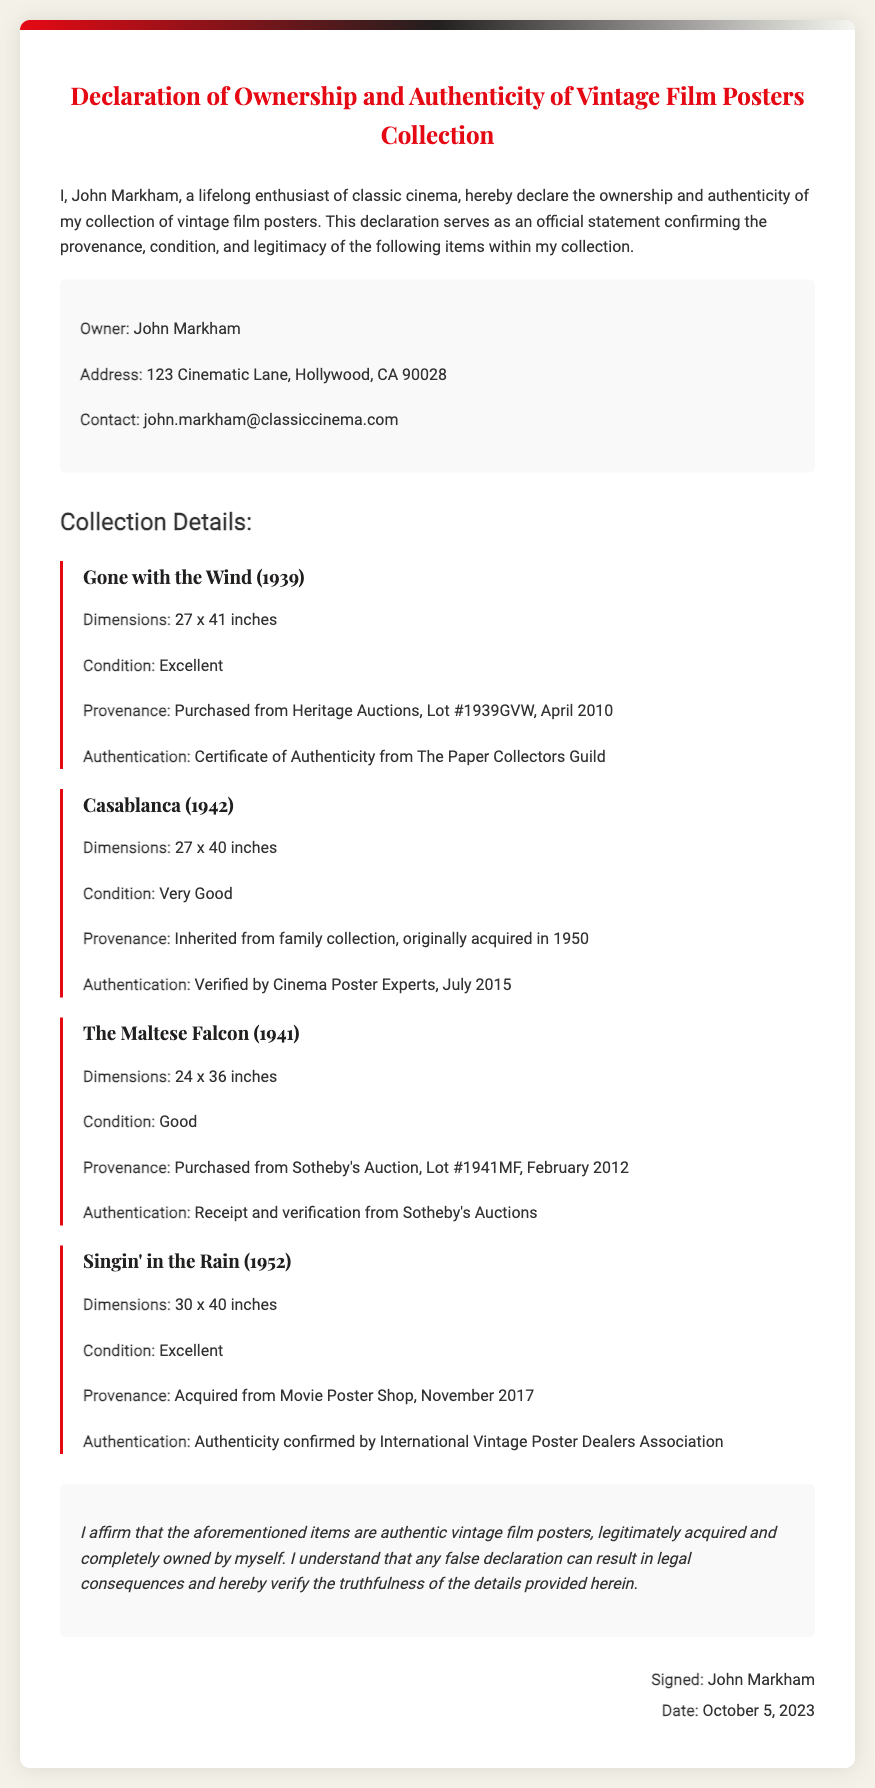What is the owner's name? The document includes a section identifying the owner, which states "John Markham."
Answer: John Markham What is the address of the owner? The owner's address is specified in the owner information section as "123 Cinematic Lane, Hollywood, CA 90028."
Answer: 123 Cinematic Lane, Hollywood, CA 90028 What is the condition of the "Gone with the Wind" poster? The condition of the poster is provided in the collection details, indicated as "Excellent."
Answer: Excellent When was the "Casablanca" poster originally acquired? The provenance of the "Casablanca" poster mentions it was acquired "in 1950."
Answer: 1950 How many posters are listed in the collection? The document lists four specific posters in the collection details.
Answer: Four What type of document is this? The title of the document clearly states it is a "Declaration of Ownership and Authenticity of Vintage Film Posters Collection."
Answer: Declaration What is the date of signature? The signature section concludes with the date "October 5, 2023."
Answer: October 5, 2023 What is the authentication source for the "Singin' in the Rain" poster? The authentication information indicates it is "confirmed by International Vintage Poster Dealers Association."
Answer: International Vintage Poster Dealers Association What does John Markham affirm in the declaration? John Markham affirms that the items are "authentic vintage film posters."
Answer: authentic vintage film posters 